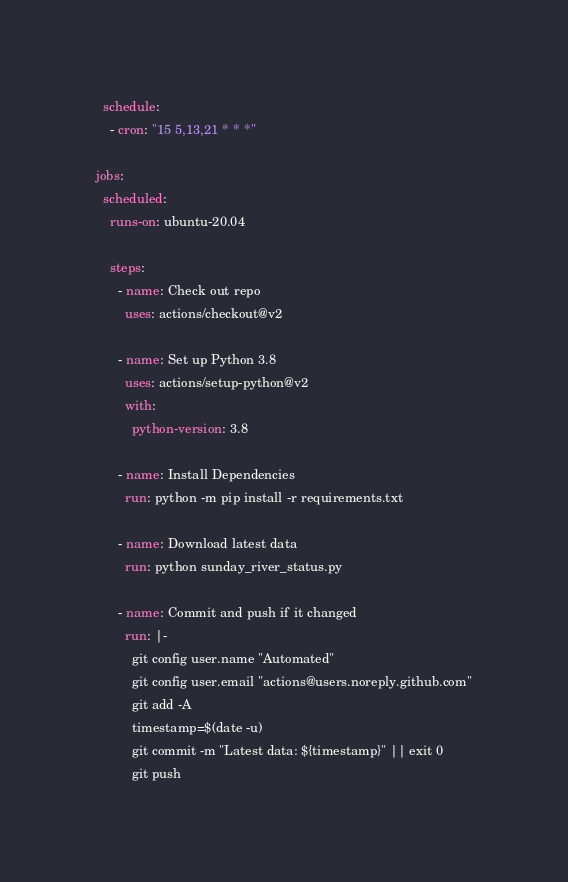Convert code to text. <code><loc_0><loc_0><loc_500><loc_500><_YAML_>  schedule:
    - cron: "15 5,13,21 * * *"

jobs:
  scheduled:
    runs-on: ubuntu-20.04

    steps:
      - name: Check out repo
        uses: actions/checkout@v2

      - name: Set up Python 3.8
        uses: actions/setup-python@v2
        with:
          python-version: 3.8

      - name: Install Dependencies
        run: python -m pip install -r requirements.txt

      - name: Download latest data
        run: python sunday_river_status.py

      - name: Commit and push if it changed
        run: |-
          git config user.name "Automated"
          git config user.email "actions@users.noreply.github.com"
          git add -A
          timestamp=$(date -u)
          git commit -m "Latest data: ${timestamp}" || exit 0
          git push
</code> 